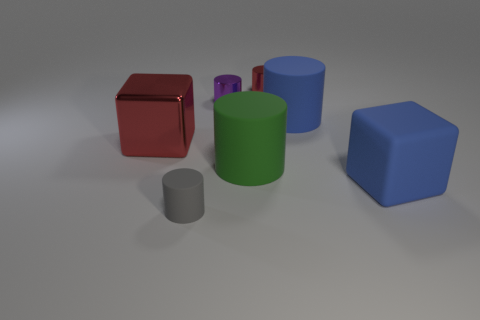Is the color of the large shiny block the same as the small rubber thing?
Make the answer very short. No. What is the size of the red metallic thing on the left side of the tiny red cylinder?
Give a very brief answer. Large. There is a shiny object to the left of the gray cylinder; is it the same color as the cube to the right of the small gray thing?
Offer a terse response. No. What number of other objects are the same shape as the purple metallic object?
Make the answer very short. 4. Are there the same number of small gray cylinders that are behind the small matte object and small purple metallic cylinders to the left of the big red metal thing?
Provide a succinct answer. Yes. Do the object that is left of the small gray rubber cylinder and the tiny object that is in front of the large blue matte cube have the same material?
Ensure brevity in your answer.  No. What number of other things are the same size as the blue rubber cube?
Ensure brevity in your answer.  3. How many things are either big green rubber cylinders or big cubes that are on the right side of the purple thing?
Your response must be concise. 2. Are there an equal number of green matte cylinders that are in front of the small gray thing and green rubber objects?
Make the answer very short. No. There is a small purple thing that is the same material as the small red object; what shape is it?
Make the answer very short. Cylinder. 